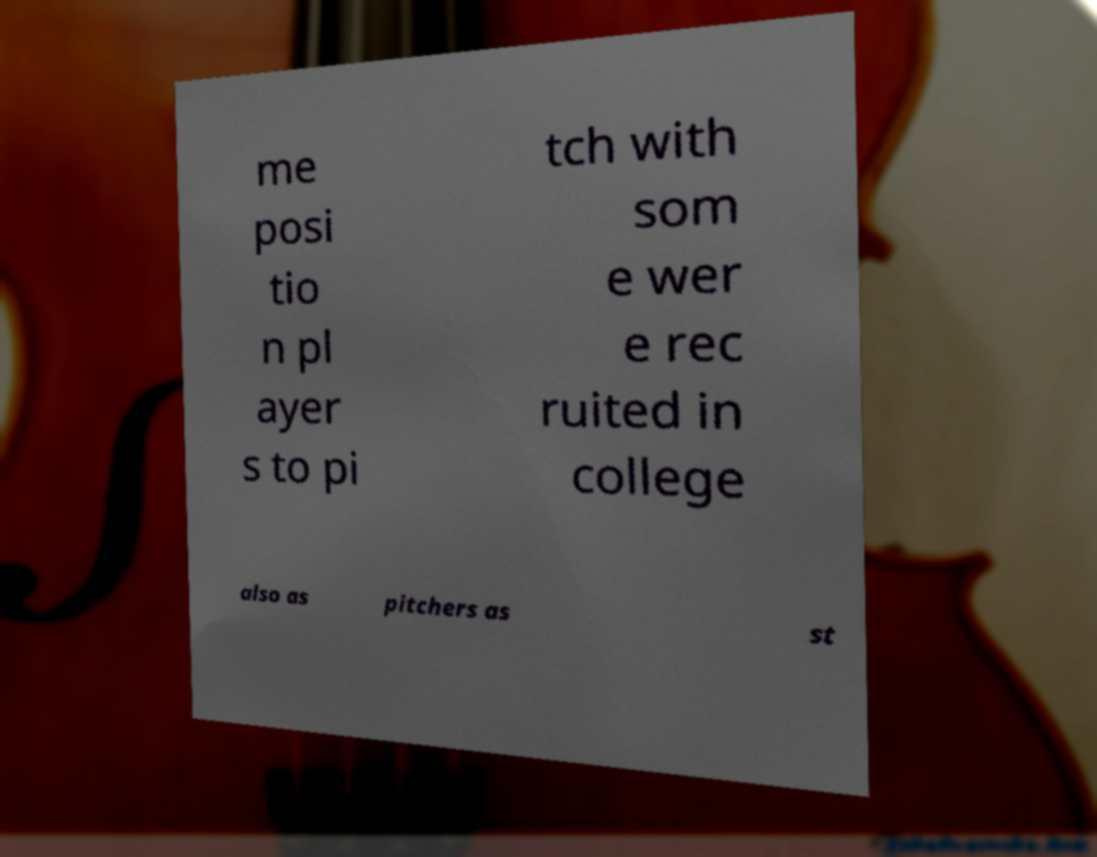Could you assist in decoding the text presented in this image and type it out clearly? me posi tio n pl ayer s to pi tch with som e wer e rec ruited in college also as pitchers as st 